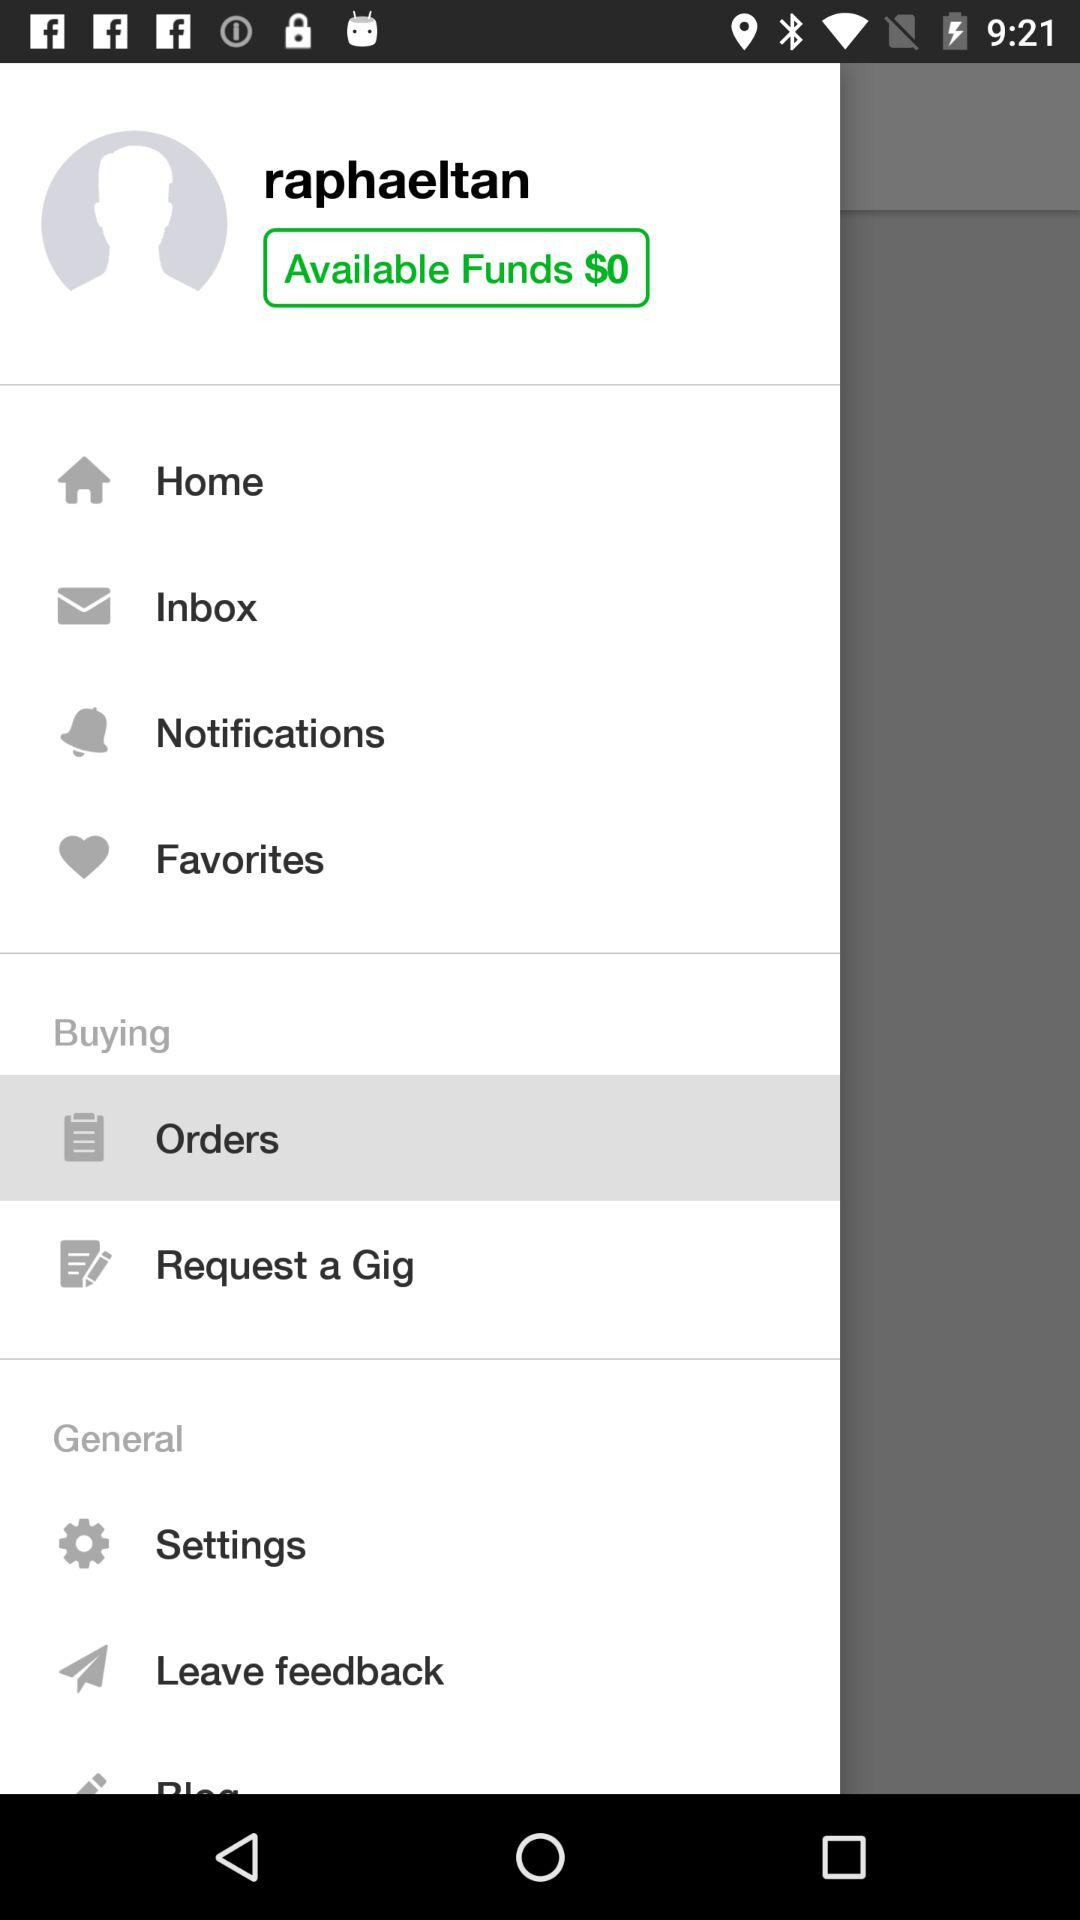What is the username? The username is "raphaeltan". 